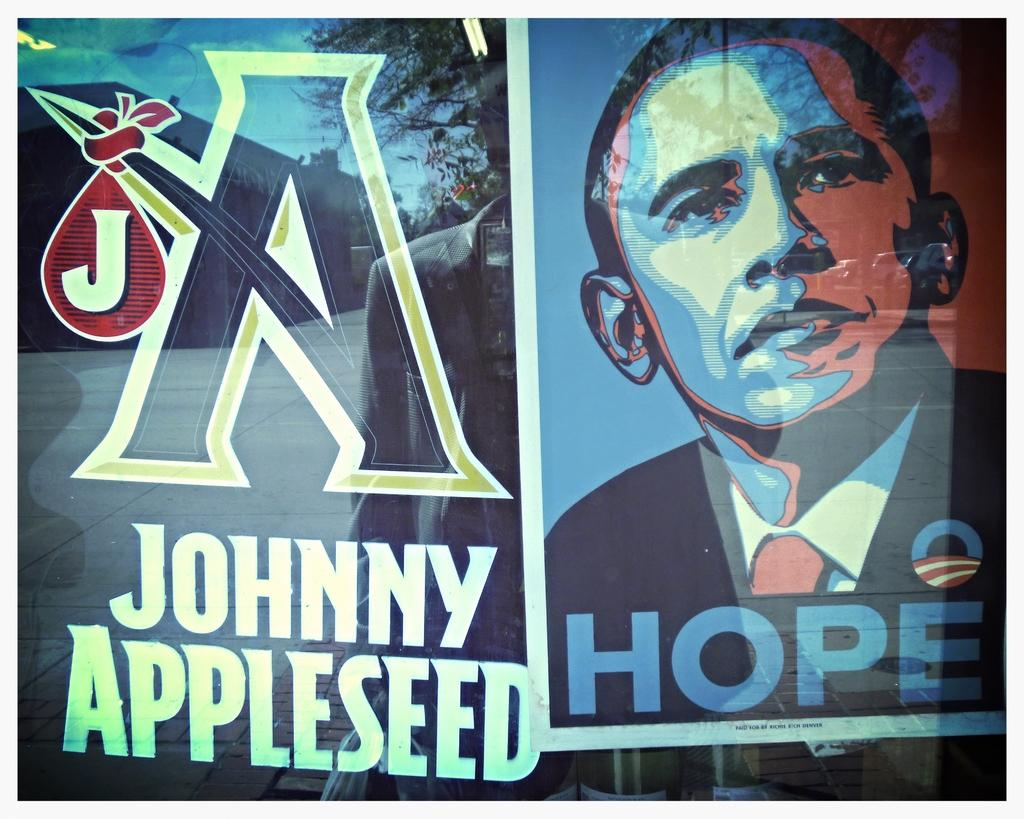<image>
Create a compact narrative representing the image presented. a Johnny Appleseed and Obama Hope poster next to one another. 